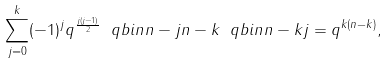Convert formula to latex. <formula><loc_0><loc_0><loc_500><loc_500>\sum _ { j = 0 } ^ { k } ( - 1 ) ^ { j } q ^ { \frac { j ( j - 1 ) } 2 } \ q b i n { n - j } { n - k } \ q b i n { n - k } { j } = q ^ { k ( n - k ) } ,</formula> 